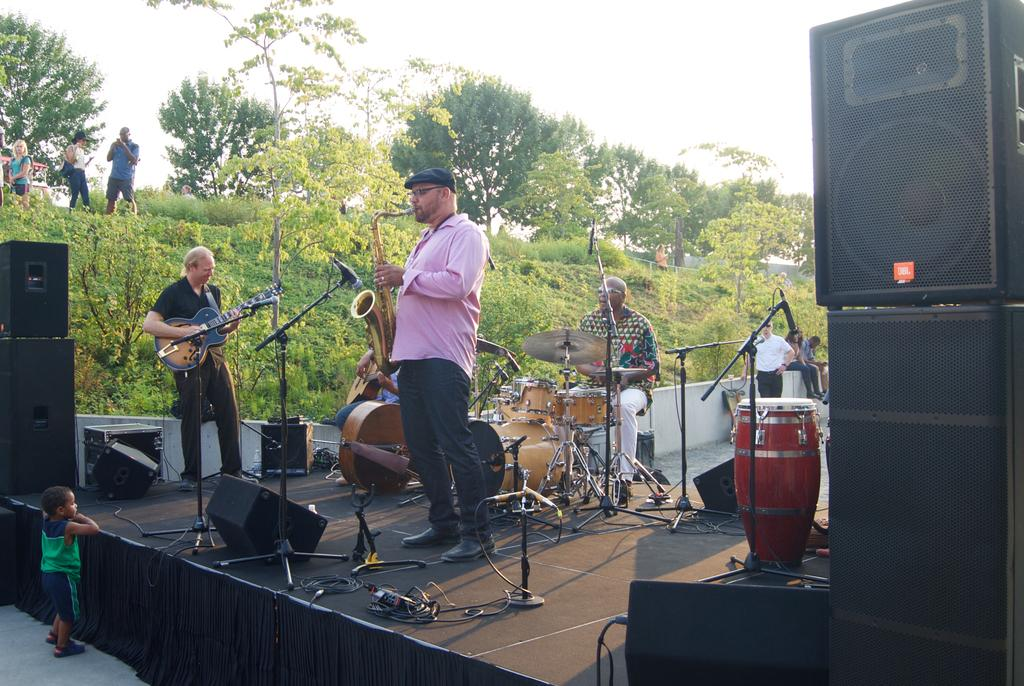What can be seen in the sky in the image? The sky is visible in the image, but no specific details about the sky are provided. What type of vegetation is present in the image? There are trees and grass in the image. What object is used for amplifying sound in the image? There is a sound box in the image. What are the people in the image doing? The people in the image are playing musical instruments. How does the sound box rest on the grass in the image? There is no information about the sound box resting on the grass in the image. The sound box could be placed on a different surface or not touching the ground at all. 